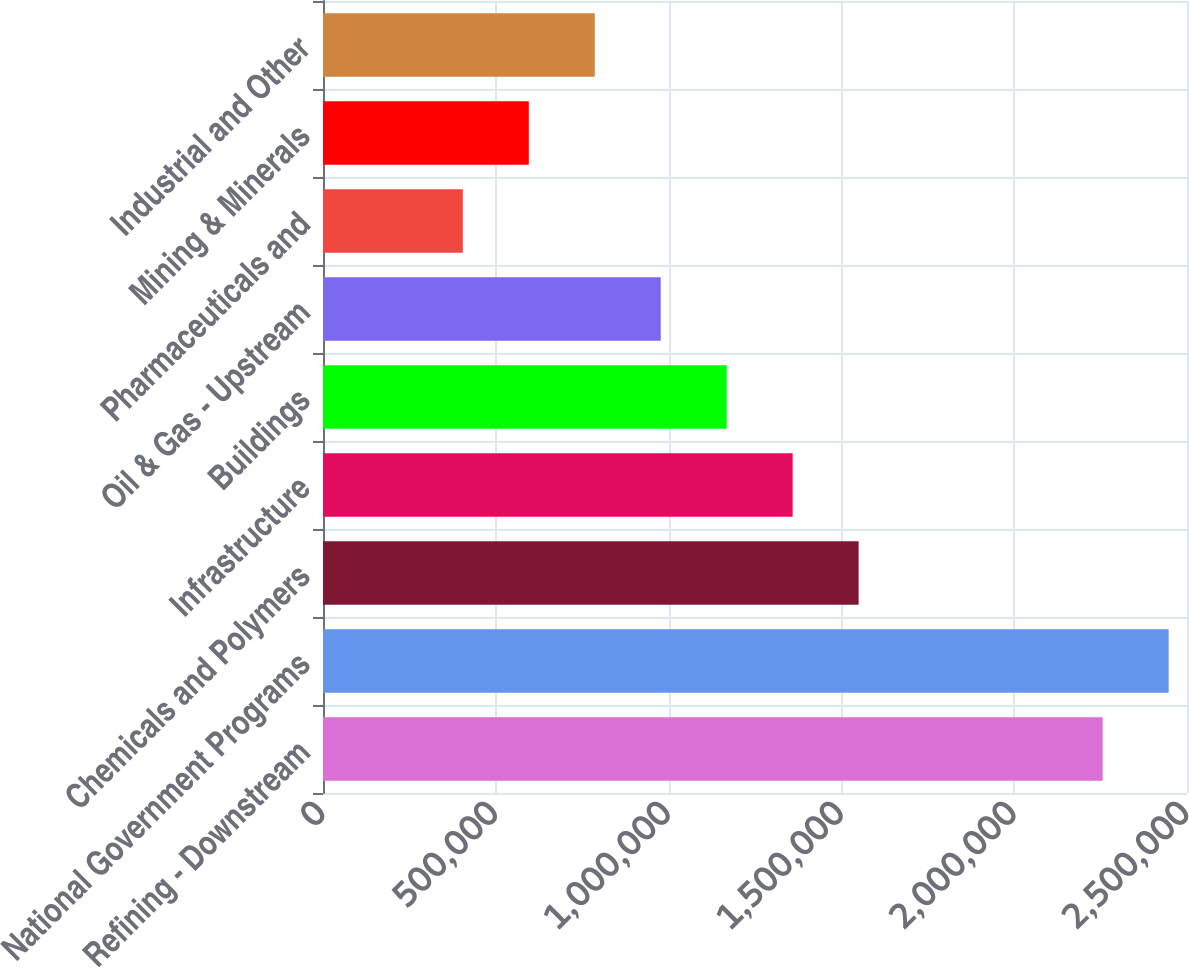Convert chart to OTSL. <chart><loc_0><loc_0><loc_500><loc_500><bar_chart><fcel>Refining - Downstream<fcel>National Government Programs<fcel>Chemicals and Polymers<fcel>Infrastructure<fcel>Buildings<fcel>Oil & Gas - Upstream<fcel>Pharmaceuticals and<fcel>Mining & Minerals<fcel>Industrial and Other<nl><fcel>2.25609e+06<fcel>2.44695e+06<fcel>1.54982e+06<fcel>1.35896e+06<fcel>1.16811e+06<fcel>977253<fcel>404687<fcel>595542<fcel>786398<nl></chart> 